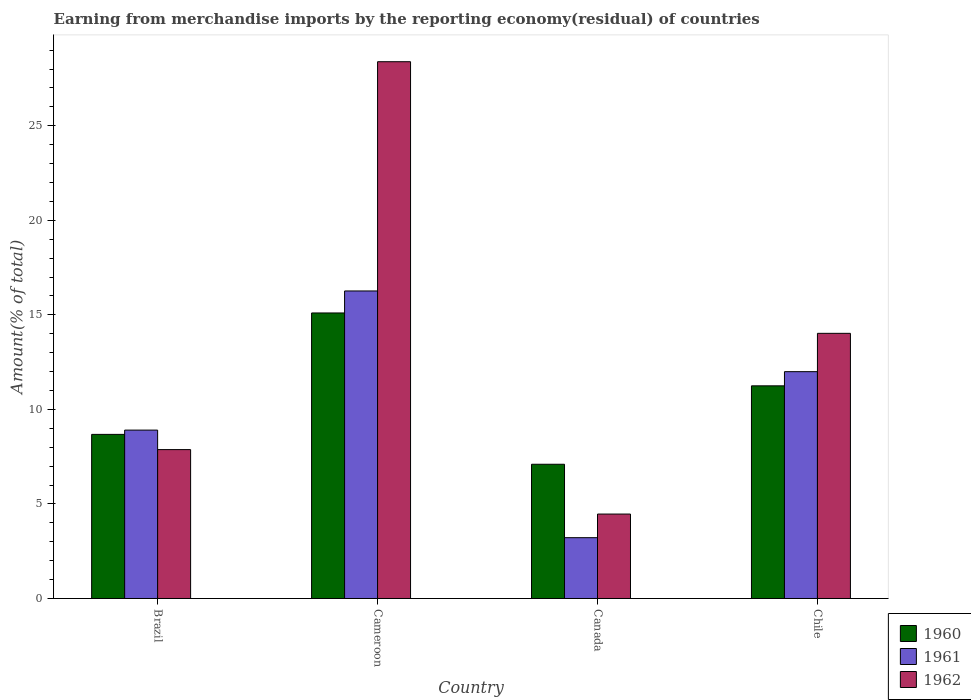How many bars are there on the 4th tick from the left?
Ensure brevity in your answer.  3. What is the label of the 2nd group of bars from the left?
Offer a terse response. Cameroon. What is the percentage of amount earned from merchandise imports in 1962 in Cameroon?
Offer a terse response. 28.39. Across all countries, what is the maximum percentage of amount earned from merchandise imports in 1962?
Make the answer very short. 28.39. Across all countries, what is the minimum percentage of amount earned from merchandise imports in 1961?
Offer a terse response. 3.22. In which country was the percentage of amount earned from merchandise imports in 1961 maximum?
Provide a short and direct response. Cameroon. What is the total percentage of amount earned from merchandise imports in 1961 in the graph?
Your response must be concise. 40.38. What is the difference between the percentage of amount earned from merchandise imports in 1962 in Brazil and that in Chile?
Give a very brief answer. -6.15. What is the difference between the percentage of amount earned from merchandise imports in 1962 in Canada and the percentage of amount earned from merchandise imports in 1961 in Chile?
Give a very brief answer. -7.53. What is the average percentage of amount earned from merchandise imports in 1962 per country?
Offer a very short reply. 13.69. What is the difference between the percentage of amount earned from merchandise imports of/in 1962 and percentage of amount earned from merchandise imports of/in 1961 in Chile?
Provide a short and direct response. 2.03. What is the ratio of the percentage of amount earned from merchandise imports in 1961 in Canada to that in Chile?
Provide a succinct answer. 0.27. Is the percentage of amount earned from merchandise imports in 1960 in Brazil less than that in Cameroon?
Provide a short and direct response. Yes. Is the difference between the percentage of amount earned from merchandise imports in 1962 in Cameroon and Canada greater than the difference between the percentage of amount earned from merchandise imports in 1961 in Cameroon and Canada?
Make the answer very short. Yes. What is the difference between the highest and the second highest percentage of amount earned from merchandise imports in 1960?
Your answer should be very brief. -2.57. What is the difference between the highest and the lowest percentage of amount earned from merchandise imports in 1960?
Provide a short and direct response. 8. In how many countries, is the percentage of amount earned from merchandise imports in 1960 greater than the average percentage of amount earned from merchandise imports in 1960 taken over all countries?
Your response must be concise. 2. What does the 2nd bar from the left in Chile represents?
Give a very brief answer. 1961. Is it the case that in every country, the sum of the percentage of amount earned from merchandise imports in 1961 and percentage of amount earned from merchandise imports in 1962 is greater than the percentage of amount earned from merchandise imports in 1960?
Provide a succinct answer. Yes. How many bars are there?
Your answer should be very brief. 12. How many countries are there in the graph?
Ensure brevity in your answer.  4. What is the difference between two consecutive major ticks on the Y-axis?
Give a very brief answer. 5. Does the graph contain any zero values?
Make the answer very short. No. How many legend labels are there?
Ensure brevity in your answer.  3. What is the title of the graph?
Your answer should be compact. Earning from merchandise imports by the reporting economy(residual) of countries. Does "1967" appear as one of the legend labels in the graph?
Offer a very short reply. No. What is the label or title of the Y-axis?
Provide a short and direct response. Amount(% of total). What is the Amount(% of total) of 1960 in Brazil?
Provide a short and direct response. 8.68. What is the Amount(% of total) in 1961 in Brazil?
Offer a terse response. 8.91. What is the Amount(% of total) of 1962 in Brazil?
Your answer should be compact. 7.87. What is the Amount(% of total) in 1960 in Cameroon?
Offer a very short reply. 15.1. What is the Amount(% of total) in 1961 in Cameroon?
Offer a very short reply. 16.26. What is the Amount(% of total) of 1962 in Cameroon?
Provide a short and direct response. 28.39. What is the Amount(% of total) of 1960 in Canada?
Provide a succinct answer. 7.1. What is the Amount(% of total) of 1961 in Canada?
Offer a very short reply. 3.22. What is the Amount(% of total) in 1962 in Canada?
Make the answer very short. 4.47. What is the Amount(% of total) in 1960 in Chile?
Offer a very short reply. 11.25. What is the Amount(% of total) of 1961 in Chile?
Your response must be concise. 12. What is the Amount(% of total) of 1962 in Chile?
Give a very brief answer. 14.02. Across all countries, what is the maximum Amount(% of total) of 1960?
Offer a terse response. 15.1. Across all countries, what is the maximum Amount(% of total) of 1961?
Provide a succinct answer. 16.26. Across all countries, what is the maximum Amount(% of total) in 1962?
Provide a succinct answer. 28.39. Across all countries, what is the minimum Amount(% of total) in 1960?
Your answer should be very brief. 7.1. Across all countries, what is the minimum Amount(% of total) in 1961?
Offer a terse response. 3.22. Across all countries, what is the minimum Amount(% of total) of 1962?
Your response must be concise. 4.47. What is the total Amount(% of total) in 1960 in the graph?
Make the answer very short. 42.13. What is the total Amount(% of total) in 1961 in the graph?
Ensure brevity in your answer.  40.38. What is the total Amount(% of total) of 1962 in the graph?
Offer a very short reply. 54.75. What is the difference between the Amount(% of total) in 1960 in Brazil and that in Cameroon?
Give a very brief answer. -6.42. What is the difference between the Amount(% of total) in 1961 in Brazil and that in Cameroon?
Make the answer very short. -7.36. What is the difference between the Amount(% of total) in 1962 in Brazil and that in Cameroon?
Provide a short and direct response. -20.51. What is the difference between the Amount(% of total) of 1960 in Brazil and that in Canada?
Offer a terse response. 1.58. What is the difference between the Amount(% of total) of 1961 in Brazil and that in Canada?
Offer a very short reply. 5.69. What is the difference between the Amount(% of total) in 1962 in Brazil and that in Canada?
Keep it short and to the point. 3.41. What is the difference between the Amount(% of total) in 1960 in Brazil and that in Chile?
Offer a very short reply. -2.57. What is the difference between the Amount(% of total) in 1961 in Brazil and that in Chile?
Ensure brevity in your answer.  -3.09. What is the difference between the Amount(% of total) in 1962 in Brazil and that in Chile?
Offer a very short reply. -6.15. What is the difference between the Amount(% of total) of 1960 in Cameroon and that in Canada?
Provide a short and direct response. 8. What is the difference between the Amount(% of total) of 1961 in Cameroon and that in Canada?
Offer a terse response. 13.05. What is the difference between the Amount(% of total) in 1962 in Cameroon and that in Canada?
Make the answer very short. 23.92. What is the difference between the Amount(% of total) in 1960 in Cameroon and that in Chile?
Ensure brevity in your answer.  3.85. What is the difference between the Amount(% of total) of 1961 in Cameroon and that in Chile?
Provide a short and direct response. 4.27. What is the difference between the Amount(% of total) of 1962 in Cameroon and that in Chile?
Offer a terse response. 14.37. What is the difference between the Amount(% of total) of 1960 in Canada and that in Chile?
Make the answer very short. -4.15. What is the difference between the Amount(% of total) in 1961 in Canada and that in Chile?
Give a very brief answer. -8.78. What is the difference between the Amount(% of total) in 1962 in Canada and that in Chile?
Your answer should be compact. -9.56. What is the difference between the Amount(% of total) of 1960 in Brazil and the Amount(% of total) of 1961 in Cameroon?
Ensure brevity in your answer.  -7.59. What is the difference between the Amount(% of total) in 1960 in Brazil and the Amount(% of total) in 1962 in Cameroon?
Offer a very short reply. -19.71. What is the difference between the Amount(% of total) of 1961 in Brazil and the Amount(% of total) of 1962 in Cameroon?
Provide a succinct answer. -19.48. What is the difference between the Amount(% of total) in 1960 in Brazil and the Amount(% of total) in 1961 in Canada?
Offer a very short reply. 5.46. What is the difference between the Amount(% of total) in 1960 in Brazil and the Amount(% of total) in 1962 in Canada?
Your answer should be compact. 4.21. What is the difference between the Amount(% of total) in 1961 in Brazil and the Amount(% of total) in 1962 in Canada?
Offer a very short reply. 4.44. What is the difference between the Amount(% of total) in 1960 in Brazil and the Amount(% of total) in 1961 in Chile?
Ensure brevity in your answer.  -3.32. What is the difference between the Amount(% of total) in 1960 in Brazil and the Amount(% of total) in 1962 in Chile?
Ensure brevity in your answer.  -5.34. What is the difference between the Amount(% of total) in 1961 in Brazil and the Amount(% of total) in 1962 in Chile?
Your answer should be very brief. -5.12. What is the difference between the Amount(% of total) in 1960 in Cameroon and the Amount(% of total) in 1961 in Canada?
Your answer should be compact. 11.88. What is the difference between the Amount(% of total) in 1960 in Cameroon and the Amount(% of total) in 1962 in Canada?
Offer a terse response. 10.64. What is the difference between the Amount(% of total) of 1961 in Cameroon and the Amount(% of total) of 1962 in Canada?
Make the answer very short. 11.8. What is the difference between the Amount(% of total) of 1960 in Cameroon and the Amount(% of total) of 1961 in Chile?
Give a very brief answer. 3.11. What is the difference between the Amount(% of total) of 1960 in Cameroon and the Amount(% of total) of 1962 in Chile?
Keep it short and to the point. 1.08. What is the difference between the Amount(% of total) of 1961 in Cameroon and the Amount(% of total) of 1962 in Chile?
Keep it short and to the point. 2.24. What is the difference between the Amount(% of total) of 1960 in Canada and the Amount(% of total) of 1961 in Chile?
Give a very brief answer. -4.9. What is the difference between the Amount(% of total) in 1960 in Canada and the Amount(% of total) in 1962 in Chile?
Your answer should be compact. -6.92. What is the difference between the Amount(% of total) in 1961 in Canada and the Amount(% of total) in 1962 in Chile?
Give a very brief answer. -10.81. What is the average Amount(% of total) in 1960 per country?
Ensure brevity in your answer.  10.53. What is the average Amount(% of total) of 1961 per country?
Give a very brief answer. 10.1. What is the average Amount(% of total) in 1962 per country?
Ensure brevity in your answer.  13.69. What is the difference between the Amount(% of total) in 1960 and Amount(% of total) in 1961 in Brazil?
Provide a short and direct response. -0.23. What is the difference between the Amount(% of total) of 1960 and Amount(% of total) of 1962 in Brazil?
Give a very brief answer. 0.8. What is the difference between the Amount(% of total) in 1961 and Amount(% of total) in 1962 in Brazil?
Provide a short and direct response. 1.03. What is the difference between the Amount(% of total) in 1960 and Amount(% of total) in 1961 in Cameroon?
Give a very brief answer. -1.16. What is the difference between the Amount(% of total) of 1960 and Amount(% of total) of 1962 in Cameroon?
Make the answer very short. -13.29. What is the difference between the Amount(% of total) in 1961 and Amount(% of total) in 1962 in Cameroon?
Ensure brevity in your answer.  -12.12. What is the difference between the Amount(% of total) in 1960 and Amount(% of total) in 1961 in Canada?
Offer a very short reply. 3.88. What is the difference between the Amount(% of total) in 1960 and Amount(% of total) in 1962 in Canada?
Offer a terse response. 2.63. What is the difference between the Amount(% of total) in 1961 and Amount(% of total) in 1962 in Canada?
Your answer should be compact. -1.25. What is the difference between the Amount(% of total) of 1960 and Amount(% of total) of 1961 in Chile?
Your answer should be compact. -0.75. What is the difference between the Amount(% of total) in 1960 and Amount(% of total) in 1962 in Chile?
Your answer should be compact. -2.78. What is the difference between the Amount(% of total) of 1961 and Amount(% of total) of 1962 in Chile?
Offer a terse response. -2.03. What is the ratio of the Amount(% of total) of 1960 in Brazil to that in Cameroon?
Your response must be concise. 0.57. What is the ratio of the Amount(% of total) in 1961 in Brazil to that in Cameroon?
Your answer should be compact. 0.55. What is the ratio of the Amount(% of total) of 1962 in Brazil to that in Cameroon?
Offer a very short reply. 0.28. What is the ratio of the Amount(% of total) in 1960 in Brazil to that in Canada?
Make the answer very short. 1.22. What is the ratio of the Amount(% of total) in 1961 in Brazil to that in Canada?
Provide a succinct answer. 2.77. What is the ratio of the Amount(% of total) of 1962 in Brazil to that in Canada?
Your answer should be compact. 1.76. What is the ratio of the Amount(% of total) in 1960 in Brazil to that in Chile?
Your answer should be very brief. 0.77. What is the ratio of the Amount(% of total) in 1961 in Brazil to that in Chile?
Ensure brevity in your answer.  0.74. What is the ratio of the Amount(% of total) in 1962 in Brazil to that in Chile?
Give a very brief answer. 0.56. What is the ratio of the Amount(% of total) of 1960 in Cameroon to that in Canada?
Your response must be concise. 2.13. What is the ratio of the Amount(% of total) in 1961 in Cameroon to that in Canada?
Keep it short and to the point. 5.06. What is the ratio of the Amount(% of total) in 1962 in Cameroon to that in Canada?
Your answer should be compact. 6.36. What is the ratio of the Amount(% of total) of 1960 in Cameroon to that in Chile?
Your answer should be compact. 1.34. What is the ratio of the Amount(% of total) of 1961 in Cameroon to that in Chile?
Your response must be concise. 1.36. What is the ratio of the Amount(% of total) of 1962 in Cameroon to that in Chile?
Your response must be concise. 2.02. What is the ratio of the Amount(% of total) in 1960 in Canada to that in Chile?
Provide a short and direct response. 0.63. What is the ratio of the Amount(% of total) in 1961 in Canada to that in Chile?
Offer a terse response. 0.27. What is the ratio of the Amount(% of total) of 1962 in Canada to that in Chile?
Provide a succinct answer. 0.32. What is the difference between the highest and the second highest Amount(% of total) in 1960?
Keep it short and to the point. 3.85. What is the difference between the highest and the second highest Amount(% of total) of 1961?
Your answer should be very brief. 4.27. What is the difference between the highest and the second highest Amount(% of total) of 1962?
Offer a very short reply. 14.37. What is the difference between the highest and the lowest Amount(% of total) of 1960?
Your response must be concise. 8. What is the difference between the highest and the lowest Amount(% of total) of 1961?
Offer a terse response. 13.05. What is the difference between the highest and the lowest Amount(% of total) of 1962?
Ensure brevity in your answer.  23.92. 